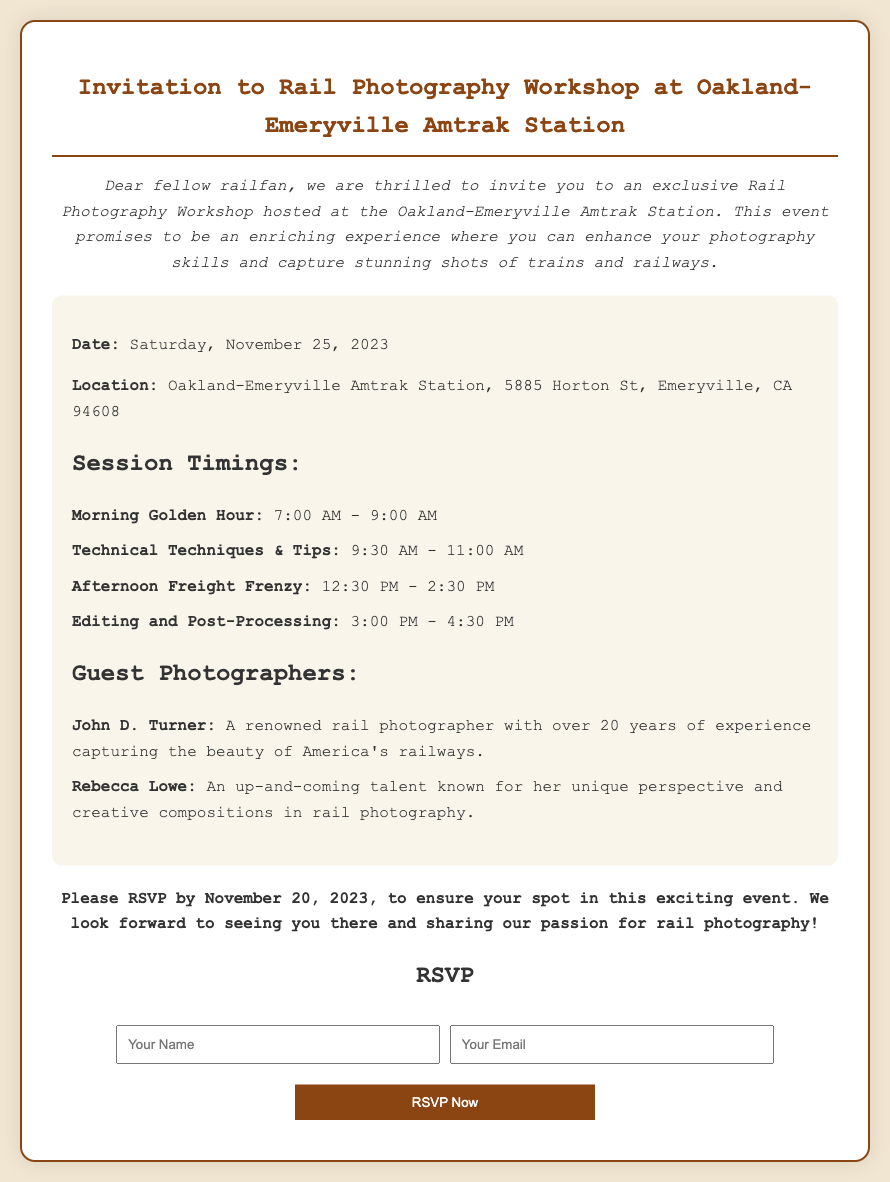What is the date of the workshop? The date of the workshop is explicitly stated in the document as Saturday, November 25, 2023.
Answer: Saturday, November 25, 2023 Where is the workshop location? The document specifies the location as Oakland-Emeryville Amtrak Station, 5885 Horton St, Emeryville, CA 94608.
Answer: Oakland-Emeryville Amtrak Station, 5885 Horton St, Emeryville, CA 94608 What time does the "Afternoon Freight Frenzy" session start? The starting time for the "Afternoon Freight Frenzy" session is mentioned in the document as 12:30 PM.
Answer: 12:30 PM Who is one of the guest photographers? The document lists John D. Turner and Rebecca Lowe as guest photographers. Asking for either name meets the requirement.
Answer: John D. Turner What is the RSVP deadline? The deadline for RSVPs is clearly stated as November 20, 2023, in the document.
Answer: November 20, 2023 How many sessions are offered during the workshop? The document lists four sessions, so the answer is counted based on the session headings in the document.
Answer: Four What is the purpose of the workshop? The document states that the workshop aims to enhance photography skills and capture stunning shots of trains and railways.
Answer: Enhance photography skills What type of document is this? The structure and content indicate that this is an RSVP card, as it includes a section to respond with attendance information.
Answer: RSVP card 